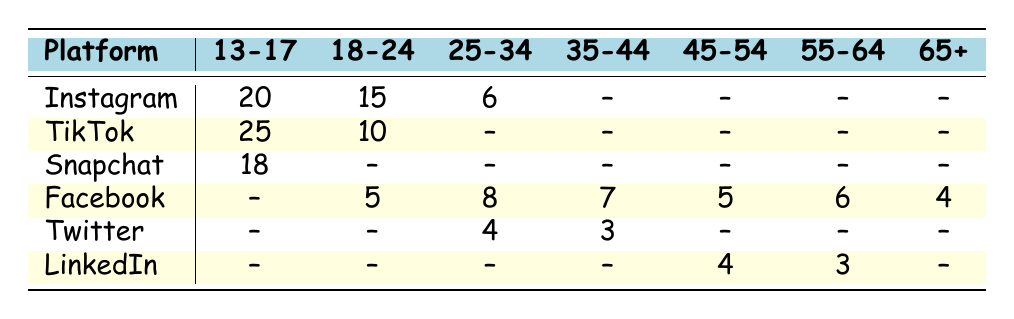What is the frequency of Instagram usage for the 13-17 age group? The table lists Instagram usage for the 13-17 age group as 20 frequencies per week.
Answer: 20 Which platform has the highest usage frequency in the 13-17 age group? TikTok has the highest frequency at 25 per week, while Instagram is second with 20.
Answer: TikTok Is there any age group that uses Twitter? Yes, Twitter is used by the 25-34 age group with a frequency of 4 and the 35-44 age group with a frequency of 3.
Answer: Yes What is the total frequency of Facebook usage across all age groups? The frequencies for Facebook by age group are 5 (18-24), 8 (25-34), 7 (35-44), 5 (45-54), 6 (55-64), and 4 (65+). Adding them gives 5 + 8 + 7 + 5 + 6 + 4 = 35.
Answer: 35 Which age group uses Snapchat, and what is the frequency? Snapchat is used by the 13-17 age group with a frequency of 18 per week.
Answer: 13-17 age group, frequency 18 Is there any age group that does not use LinkedIn? Yes, the age groups 13-17, 18-24, and 25-34 do not use LinkedIn, as their frequencies are marked as "--".
Answer: Yes What is the difference in Facebook usage frequency between the 25-34 and 35-44 age groups? The frequency for the 25-34 age group is 8, and for the 35-44 age group, it is 7. The difference is calculated as 8 - 7 = 1.
Answer: 1 How many platforms are used by the 65+ age group? The table shows only Facebook is used by the 65+ age group, with a frequency of 4.
Answer: 1 What is the average frequency of Instagram usage across all age groups that use it? Instagram is used by the age groups 13-17 (20), 18-24 (15), and 25-34 (6). The average is calculated as (20 + 15 + 6) / 3 = 41 / 3 ≈ 13.67.
Answer: 13.67 Which platform has the lowest frequency among all age groups? Twitter has the lowest frequency at 3, used by the 35-44 age group.
Answer: Twitter 